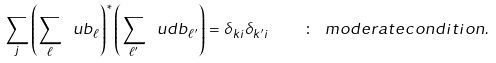<formula> <loc_0><loc_0><loc_500><loc_500>\sum _ { j } \left ( \sum _ { \ell } \ u b _ { \ell } \right ) ^ { * } \left ( \sum _ { \ell ^ { \prime } } \ u d b _ { \ell ^ { \prime } } \right ) = \delta _ { k i } \delta _ { k ^ { \prime } i } \quad \colon \ m o d e r a t e c o n d i t i o n .</formula> 